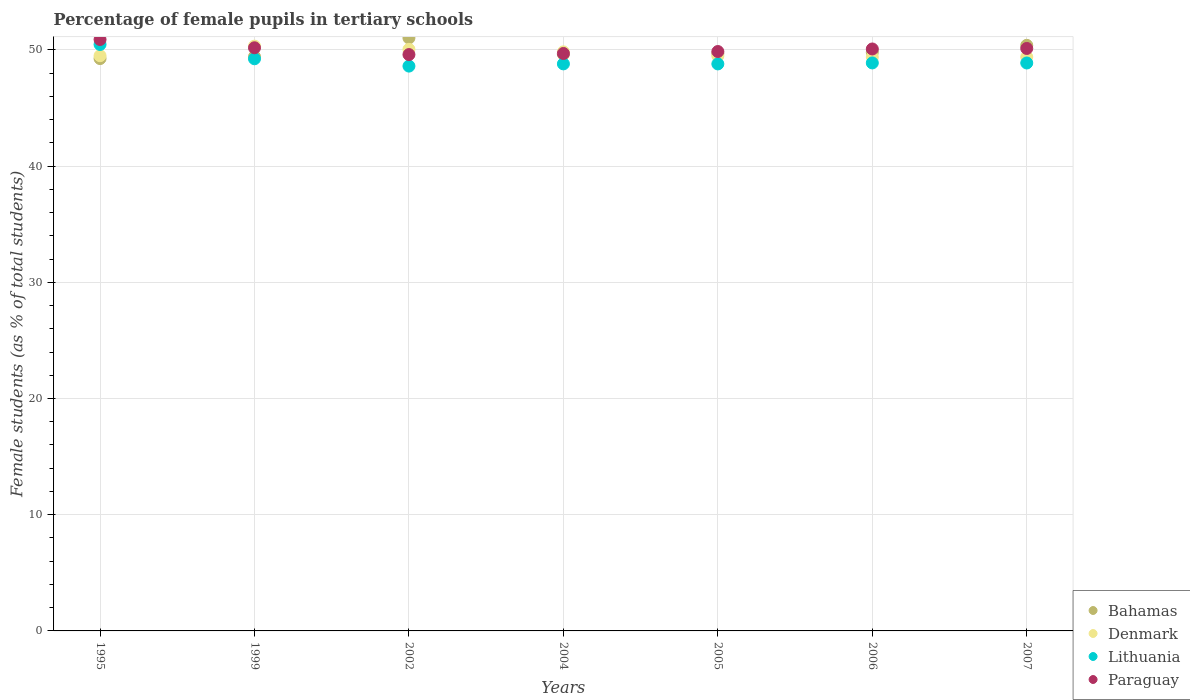Is the number of dotlines equal to the number of legend labels?
Keep it short and to the point. Yes. What is the percentage of female pupils in tertiary schools in Paraguay in 1999?
Make the answer very short. 50.18. Across all years, what is the maximum percentage of female pupils in tertiary schools in Paraguay?
Give a very brief answer. 50.9. Across all years, what is the minimum percentage of female pupils in tertiary schools in Denmark?
Provide a succinct answer. 49.38. In which year was the percentage of female pupils in tertiary schools in Denmark maximum?
Offer a terse response. 1999. What is the total percentage of female pupils in tertiary schools in Bahamas in the graph?
Your response must be concise. 349.22. What is the difference between the percentage of female pupils in tertiary schools in Lithuania in 1999 and that in 2002?
Provide a short and direct response. 0.63. What is the difference between the percentage of female pupils in tertiary schools in Denmark in 2004 and the percentage of female pupils in tertiary schools in Bahamas in 2007?
Your answer should be very brief. -0.56. What is the average percentage of female pupils in tertiary schools in Denmark per year?
Your answer should be very brief. 49.71. In the year 1995, what is the difference between the percentage of female pupils in tertiary schools in Denmark and percentage of female pupils in tertiary schools in Paraguay?
Your response must be concise. -1.4. In how many years, is the percentage of female pupils in tertiary schools in Bahamas greater than 32 %?
Provide a succinct answer. 7. What is the ratio of the percentage of female pupils in tertiary schools in Denmark in 1999 to that in 2006?
Make the answer very short. 1.02. Is the percentage of female pupils in tertiary schools in Lithuania in 1999 less than that in 2005?
Offer a very short reply. No. What is the difference between the highest and the second highest percentage of female pupils in tertiary schools in Paraguay?
Make the answer very short. 0.71. What is the difference between the highest and the lowest percentage of female pupils in tertiary schools in Denmark?
Your answer should be compact. 0.94. Is the sum of the percentage of female pupils in tertiary schools in Lithuania in 2002 and 2007 greater than the maximum percentage of female pupils in tertiary schools in Paraguay across all years?
Offer a very short reply. Yes. Is the percentage of female pupils in tertiary schools in Paraguay strictly less than the percentage of female pupils in tertiary schools in Denmark over the years?
Give a very brief answer. No. What is the difference between two consecutive major ticks on the Y-axis?
Offer a very short reply. 10. Are the values on the major ticks of Y-axis written in scientific E-notation?
Provide a short and direct response. No. How many legend labels are there?
Offer a very short reply. 4. What is the title of the graph?
Give a very brief answer. Percentage of female pupils in tertiary schools. What is the label or title of the X-axis?
Your response must be concise. Years. What is the label or title of the Y-axis?
Provide a short and direct response. Female students (as % of total students). What is the Female students (as % of total students) in Bahamas in 1995?
Keep it short and to the point. 49.25. What is the Female students (as % of total students) of Denmark in 1995?
Offer a very short reply. 49.5. What is the Female students (as % of total students) in Lithuania in 1995?
Ensure brevity in your answer.  50.47. What is the Female students (as % of total students) of Paraguay in 1995?
Your response must be concise. 50.9. What is the Female students (as % of total students) of Bahamas in 1999?
Provide a short and direct response. 49.43. What is the Female students (as % of total students) in Denmark in 1999?
Your answer should be very brief. 50.32. What is the Female students (as % of total students) in Lithuania in 1999?
Your answer should be compact. 49.24. What is the Female students (as % of total students) of Paraguay in 1999?
Make the answer very short. 50.18. What is the Female students (as % of total students) in Bahamas in 2002?
Ensure brevity in your answer.  51.03. What is the Female students (as % of total students) of Denmark in 2002?
Make the answer very short. 50.05. What is the Female students (as % of total students) of Lithuania in 2002?
Keep it short and to the point. 48.61. What is the Female students (as % of total students) in Paraguay in 2002?
Provide a short and direct response. 49.6. What is the Female students (as % of total students) in Bahamas in 2004?
Provide a short and direct response. 49.62. What is the Female students (as % of total students) in Denmark in 2004?
Ensure brevity in your answer.  49.83. What is the Female students (as % of total students) in Lithuania in 2004?
Provide a succinct answer. 48.8. What is the Female students (as % of total students) of Paraguay in 2004?
Make the answer very short. 49.69. What is the Female students (as % of total students) of Bahamas in 2005?
Ensure brevity in your answer.  49.71. What is the Female students (as % of total students) in Denmark in 2005?
Your response must be concise. 49.48. What is the Female students (as % of total students) in Lithuania in 2005?
Make the answer very short. 48.79. What is the Female students (as % of total students) in Paraguay in 2005?
Keep it short and to the point. 49.86. What is the Female students (as % of total students) of Bahamas in 2006?
Your response must be concise. 49.8. What is the Female students (as % of total students) of Denmark in 2006?
Provide a succinct answer. 49.38. What is the Female students (as % of total students) of Lithuania in 2006?
Offer a very short reply. 48.88. What is the Female students (as % of total students) of Paraguay in 2006?
Offer a terse response. 50.08. What is the Female students (as % of total students) in Bahamas in 2007?
Ensure brevity in your answer.  50.39. What is the Female students (as % of total students) of Denmark in 2007?
Your response must be concise. 49.39. What is the Female students (as % of total students) in Lithuania in 2007?
Give a very brief answer. 48.87. What is the Female students (as % of total students) in Paraguay in 2007?
Your answer should be compact. 50.12. Across all years, what is the maximum Female students (as % of total students) of Bahamas?
Your response must be concise. 51.03. Across all years, what is the maximum Female students (as % of total students) in Denmark?
Make the answer very short. 50.32. Across all years, what is the maximum Female students (as % of total students) of Lithuania?
Offer a very short reply. 50.47. Across all years, what is the maximum Female students (as % of total students) of Paraguay?
Your response must be concise. 50.9. Across all years, what is the minimum Female students (as % of total students) in Bahamas?
Keep it short and to the point. 49.25. Across all years, what is the minimum Female students (as % of total students) of Denmark?
Provide a succinct answer. 49.38. Across all years, what is the minimum Female students (as % of total students) in Lithuania?
Your response must be concise. 48.61. Across all years, what is the minimum Female students (as % of total students) in Paraguay?
Keep it short and to the point. 49.6. What is the total Female students (as % of total students) in Bahamas in the graph?
Your response must be concise. 349.23. What is the total Female students (as % of total students) in Denmark in the graph?
Your response must be concise. 347.96. What is the total Female students (as % of total students) of Lithuania in the graph?
Give a very brief answer. 343.66. What is the total Female students (as % of total students) in Paraguay in the graph?
Offer a very short reply. 350.44. What is the difference between the Female students (as % of total students) in Bahamas in 1995 and that in 1999?
Provide a succinct answer. -0.17. What is the difference between the Female students (as % of total students) of Denmark in 1995 and that in 1999?
Give a very brief answer. -0.82. What is the difference between the Female students (as % of total students) of Lithuania in 1995 and that in 1999?
Offer a very short reply. 1.23. What is the difference between the Female students (as % of total students) of Paraguay in 1995 and that in 1999?
Provide a succinct answer. 0.71. What is the difference between the Female students (as % of total students) of Bahamas in 1995 and that in 2002?
Offer a terse response. -1.77. What is the difference between the Female students (as % of total students) in Denmark in 1995 and that in 2002?
Keep it short and to the point. -0.55. What is the difference between the Female students (as % of total students) in Lithuania in 1995 and that in 2002?
Your answer should be very brief. 1.86. What is the difference between the Female students (as % of total students) of Paraguay in 1995 and that in 2002?
Provide a short and direct response. 1.3. What is the difference between the Female students (as % of total students) in Bahamas in 1995 and that in 2004?
Provide a short and direct response. -0.37. What is the difference between the Female students (as % of total students) in Denmark in 1995 and that in 2004?
Your response must be concise. -0.33. What is the difference between the Female students (as % of total students) in Lithuania in 1995 and that in 2004?
Your response must be concise. 1.67. What is the difference between the Female students (as % of total students) of Paraguay in 1995 and that in 2004?
Make the answer very short. 1.2. What is the difference between the Female students (as % of total students) of Bahamas in 1995 and that in 2005?
Your answer should be very brief. -0.45. What is the difference between the Female students (as % of total students) in Denmark in 1995 and that in 2005?
Ensure brevity in your answer.  0.02. What is the difference between the Female students (as % of total students) of Lithuania in 1995 and that in 2005?
Offer a terse response. 1.67. What is the difference between the Female students (as % of total students) of Paraguay in 1995 and that in 2005?
Ensure brevity in your answer.  1.04. What is the difference between the Female students (as % of total students) of Bahamas in 1995 and that in 2006?
Provide a succinct answer. -0.55. What is the difference between the Female students (as % of total students) in Denmark in 1995 and that in 2006?
Offer a terse response. 0.12. What is the difference between the Female students (as % of total students) of Lithuania in 1995 and that in 2006?
Offer a very short reply. 1.59. What is the difference between the Female students (as % of total students) in Paraguay in 1995 and that in 2006?
Ensure brevity in your answer.  0.82. What is the difference between the Female students (as % of total students) in Bahamas in 1995 and that in 2007?
Make the answer very short. -1.14. What is the difference between the Female students (as % of total students) in Denmark in 1995 and that in 2007?
Your answer should be compact. 0.11. What is the difference between the Female students (as % of total students) in Lithuania in 1995 and that in 2007?
Provide a succinct answer. 1.59. What is the difference between the Female students (as % of total students) of Paraguay in 1995 and that in 2007?
Keep it short and to the point. 0.77. What is the difference between the Female students (as % of total students) of Bahamas in 1999 and that in 2002?
Your answer should be very brief. -1.6. What is the difference between the Female students (as % of total students) in Denmark in 1999 and that in 2002?
Offer a very short reply. 0.28. What is the difference between the Female students (as % of total students) of Lithuania in 1999 and that in 2002?
Offer a very short reply. 0.63. What is the difference between the Female students (as % of total students) in Paraguay in 1999 and that in 2002?
Your answer should be very brief. 0.59. What is the difference between the Female students (as % of total students) of Bahamas in 1999 and that in 2004?
Keep it short and to the point. -0.2. What is the difference between the Female students (as % of total students) of Denmark in 1999 and that in 2004?
Provide a succinct answer. 0.49. What is the difference between the Female students (as % of total students) of Lithuania in 1999 and that in 2004?
Provide a succinct answer. 0.44. What is the difference between the Female students (as % of total students) of Paraguay in 1999 and that in 2004?
Your answer should be very brief. 0.49. What is the difference between the Female students (as % of total students) in Bahamas in 1999 and that in 2005?
Provide a succinct answer. -0.28. What is the difference between the Female students (as % of total students) in Denmark in 1999 and that in 2005?
Keep it short and to the point. 0.84. What is the difference between the Female students (as % of total students) of Lithuania in 1999 and that in 2005?
Offer a very short reply. 0.44. What is the difference between the Female students (as % of total students) in Paraguay in 1999 and that in 2005?
Keep it short and to the point. 0.32. What is the difference between the Female students (as % of total students) in Bahamas in 1999 and that in 2006?
Keep it short and to the point. -0.37. What is the difference between the Female students (as % of total students) in Denmark in 1999 and that in 2006?
Offer a very short reply. 0.94. What is the difference between the Female students (as % of total students) in Lithuania in 1999 and that in 2006?
Give a very brief answer. 0.36. What is the difference between the Female students (as % of total students) in Paraguay in 1999 and that in 2006?
Provide a short and direct response. 0.1. What is the difference between the Female students (as % of total students) in Bahamas in 1999 and that in 2007?
Your answer should be very brief. -0.97. What is the difference between the Female students (as % of total students) in Denmark in 1999 and that in 2007?
Give a very brief answer. 0.93. What is the difference between the Female students (as % of total students) of Lithuania in 1999 and that in 2007?
Your answer should be very brief. 0.36. What is the difference between the Female students (as % of total students) in Paraguay in 1999 and that in 2007?
Offer a terse response. 0.06. What is the difference between the Female students (as % of total students) in Bahamas in 2002 and that in 2004?
Ensure brevity in your answer.  1.4. What is the difference between the Female students (as % of total students) of Denmark in 2002 and that in 2004?
Your response must be concise. 0.22. What is the difference between the Female students (as % of total students) of Lithuania in 2002 and that in 2004?
Provide a short and direct response. -0.19. What is the difference between the Female students (as % of total students) of Paraguay in 2002 and that in 2004?
Make the answer very short. -0.09. What is the difference between the Female students (as % of total students) in Bahamas in 2002 and that in 2005?
Offer a terse response. 1.32. What is the difference between the Female students (as % of total students) in Denmark in 2002 and that in 2005?
Your answer should be very brief. 0.57. What is the difference between the Female students (as % of total students) of Lithuania in 2002 and that in 2005?
Offer a very short reply. -0.19. What is the difference between the Female students (as % of total students) of Paraguay in 2002 and that in 2005?
Provide a short and direct response. -0.26. What is the difference between the Female students (as % of total students) in Bahamas in 2002 and that in 2006?
Ensure brevity in your answer.  1.23. What is the difference between the Female students (as % of total students) of Denmark in 2002 and that in 2006?
Make the answer very short. 0.67. What is the difference between the Female students (as % of total students) in Lithuania in 2002 and that in 2006?
Ensure brevity in your answer.  -0.27. What is the difference between the Female students (as % of total students) in Paraguay in 2002 and that in 2006?
Your answer should be very brief. -0.48. What is the difference between the Female students (as % of total students) of Bahamas in 2002 and that in 2007?
Make the answer very short. 0.63. What is the difference between the Female students (as % of total students) in Denmark in 2002 and that in 2007?
Offer a terse response. 0.66. What is the difference between the Female students (as % of total students) in Lithuania in 2002 and that in 2007?
Your answer should be very brief. -0.27. What is the difference between the Female students (as % of total students) in Paraguay in 2002 and that in 2007?
Offer a terse response. -0.53. What is the difference between the Female students (as % of total students) of Bahamas in 2004 and that in 2005?
Give a very brief answer. -0.08. What is the difference between the Female students (as % of total students) in Denmark in 2004 and that in 2005?
Your answer should be compact. 0.35. What is the difference between the Female students (as % of total students) in Lithuania in 2004 and that in 2005?
Give a very brief answer. 0. What is the difference between the Female students (as % of total students) in Paraguay in 2004 and that in 2005?
Give a very brief answer. -0.17. What is the difference between the Female students (as % of total students) of Bahamas in 2004 and that in 2006?
Give a very brief answer. -0.18. What is the difference between the Female students (as % of total students) in Denmark in 2004 and that in 2006?
Ensure brevity in your answer.  0.45. What is the difference between the Female students (as % of total students) of Lithuania in 2004 and that in 2006?
Give a very brief answer. -0.08. What is the difference between the Female students (as % of total students) in Paraguay in 2004 and that in 2006?
Offer a terse response. -0.39. What is the difference between the Female students (as % of total students) in Bahamas in 2004 and that in 2007?
Offer a very short reply. -0.77. What is the difference between the Female students (as % of total students) of Denmark in 2004 and that in 2007?
Keep it short and to the point. 0.44. What is the difference between the Female students (as % of total students) in Lithuania in 2004 and that in 2007?
Keep it short and to the point. -0.08. What is the difference between the Female students (as % of total students) in Paraguay in 2004 and that in 2007?
Provide a succinct answer. -0.43. What is the difference between the Female students (as % of total students) in Bahamas in 2005 and that in 2006?
Ensure brevity in your answer.  -0.09. What is the difference between the Female students (as % of total students) in Denmark in 2005 and that in 2006?
Provide a succinct answer. 0.1. What is the difference between the Female students (as % of total students) of Lithuania in 2005 and that in 2006?
Your answer should be very brief. -0.09. What is the difference between the Female students (as % of total students) of Paraguay in 2005 and that in 2006?
Provide a short and direct response. -0.22. What is the difference between the Female students (as % of total students) in Bahamas in 2005 and that in 2007?
Ensure brevity in your answer.  -0.69. What is the difference between the Female students (as % of total students) of Denmark in 2005 and that in 2007?
Keep it short and to the point. 0.09. What is the difference between the Female students (as % of total students) of Lithuania in 2005 and that in 2007?
Your response must be concise. -0.08. What is the difference between the Female students (as % of total students) in Paraguay in 2005 and that in 2007?
Keep it short and to the point. -0.26. What is the difference between the Female students (as % of total students) in Bahamas in 2006 and that in 2007?
Your response must be concise. -0.59. What is the difference between the Female students (as % of total students) in Denmark in 2006 and that in 2007?
Make the answer very short. -0.01. What is the difference between the Female students (as % of total students) of Lithuania in 2006 and that in 2007?
Give a very brief answer. 0.01. What is the difference between the Female students (as % of total students) in Paraguay in 2006 and that in 2007?
Provide a short and direct response. -0.04. What is the difference between the Female students (as % of total students) of Bahamas in 1995 and the Female students (as % of total students) of Denmark in 1999?
Provide a short and direct response. -1.07. What is the difference between the Female students (as % of total students) in Bahamas in 1995 and the Female students (as % of total students) in Lithuania in 1999?
Offer a terse response. 0.02. What is the difference between the Female students (as % of total students) of Bahamas in 1995 and the Female students (as % of total students) of Paraguay in 1999?
Provide a succinct answer. -0.93. What is the difference between the Female students (as % of total students) of Denmark in 1995 and the Female students (as % of total students) of Lithuania in 1999?
Keep it short and to the point. 0.26. What is the difference between the Female students (as % of total students) of Denmark in 1995 and the Female students (as % of total students) of Paraguay in 1999?
Make the answer very short. -0.68. What is the difference between the Female students (as % of total students) in Lithuania in 1995 and the Female students (as % of total students) in Paraguay in 1999?
Your answer should be very brief. 0.28. What is the difference between the Female students (as % of total students) in Bahamas in 1995 and the Female students (as % of total students) in Denmark in 2002?
Give a very brief answer. -0.8. What is the difference between the Female students (as % of total students) in Bahamas in 1995 and the Female students (as % of total students) in Lithuania in 2002?
Keep it short and to the point. 0.65. What is the difference between the Female students (as % of total students) of Bahamas in 1995 and the Female students (as % of total students) of Paraguay in 2002?
Your answer should be compact. -0.35. What is the difference between the Female students (as % of total students) of Denmark in 1995 and the Female students (as % of total students) of Lithuania in 2002?
Offer a terse response. 0.89. What is the difference between the Female students (as % of total students) of Denmark in 1995 and the Female students (as % of total students) of Paraguay in 2002?
Ensure brevity in your answer.  -0.1. What is the difference between the Female students (as % of total students) of Lithuania in 1995 and the Female students (as % of total students) of Paraguay in 2002?
Provide a succinct answer. 0.87. What is the difference between the Female students (as % of total students) of Bahamas in 1995 and the Female students (as % of total students) of Denmark in 2004?
Offer a terse response. -0.58. What is the difference between the Female students (as % of total students) in Bahamas in 1995 and the Female students (as % of total students) in Lithuania in 2004?
Give a very brief answer. 0.46. What is the difference between the Female students (as % of total students) in Bahamas in 1995 and the Female students (as % of total students) in Paraguay in 2004?
Your response must be concise. -0.44. What is the difference between the Female students (as % of total students) of Denmark in 1995 and the Female students (as % of total students) of Lithuania in 2004?
Your response must be concise. 0.7. What is the difference between the Female students (as % of total students) of Denmark in 1995 and the Female students (as % of total students) of Paraguay in 2004?
Provide a short and direct response. -0.19. What is the difference between the Female students (as % of total students) in Lithuania in 1995 and the Female students (as % of total students) in Paraguay in 2004?
Make the answer very short. 0.77. What is the difference between the Female students (as % of total students) in Bahamas in 1995 and the Female students (as % of total students) in Denmark in 2005?
Ensure brevity in your answer.  -0.23. What is the difference between the Female students (as % of total students) in Bahamas in 1995 and the Female students (as % of total students) in Lithuania in 2005?
Ensure brevity in your answer.  0.46. What is the difference between the Female students (as % of total students) of Bahamas in 1995 and the Female students (as % of total students) of Paraguay in 2005?
Provide a short and direct response. -0.61. What is the difference between the Female students (as % of total students) in Denmark in 1995 and the Female students (as % of total students) in Lithuania in 2005?
Your answer should be very brief. 0.71. What is the difference between the Female students (as % of total students) of Denmark in 1995 and the Female students (as % of total students) of Paraguay in 2005?
Provide a succinct answer. -0.36. What is the difference between the Female students (as % of total students) in Lithuania in 1995 and the Female students (as % of total students) in Paraguay in 2005?
Your response must be concise. 0.61. What is the difference between the Female students (as % of total students) of Bahamas in 1995 and the Female students (as % of total students) of Denmark in 2006?
Your response must be concise. -0.13. What is the difference between the Female students (as % of total students) of Bahamas in 1995 and the Female students (as % of total students) of Lithuania in 2006?
Your answer should be compact. 0.37. What is the difference between the Female students (as % of total students) of Bahamas in 1995 and the Female students (as % of total students) of Paraguay in 2006?
Your response must be concise. -0.83. What is the difference between the Female students (as % of total students) in Denmark in 1995 and the Female students (as % of total students) in Lithuania in 2006?
Make the answer very short. 0.62. What is the difference between the Female students (as % of total students) in Denmark in 1995 and the Female students (as % of total students) in Paraguay in 2006?
Your response must be concise. -0.58. What is the difference between the Female students (as % of total students) in Lithuania in 1995 and the Female students (as % of total students) in Paraguay in 2006?
Your response must be concise. 0.39. What is the difference between the Female students (as % of total students) in Bahamas in 1995 and the Female students (as % of total students) in Denmark in 2007?
Provide a short and direct response. -0.14. What is the difference between the Female students (as % of total students) of Bahamas in 1995 and the Female students (as % of total students) of Lithuania in 2007?
Make the answer very short. 0.38. What is the difference between the Female students (as % of total students) in Bahamas in 1995 and the Female students (as % of total students) in Paraguay in 2007?
Offer a terse response. -0.87. What is the difference between the Female students (as % of total students) in Denmark in 1995 and the Female students (as % of total students) in Lithuania in 2007?
Keep it short and to the point. 0.63. What is the difference between the Female students (as % of total students) of Denmark in 1995 and the Female students (as % of total students) of Paraguay in 2007?
Give a very brief answer. -0.62. What is the difference between the Female students (as % of total students) in Lithuania in 1995 and the Female students (as % of total students) in Paraguay in 2007?
Ensure brevity in your answer.  0.34. What is the difference between the Female students (as % of total students) of Bahamas in 1999 and the Female students (as % of total students) of Denmark in 2002?
Keep it short and to the point. -0.62. What is the difference between the Female students (as % of total students) of Bahamas in 1999 and the Female students (as % of total students) of Lithuania in 2002?
Provide a succinct answer. 0.82. What is the difference between the Female students (as % of total students) of Bahamas in 1999 and the Female students (as % of total students) of Paraguay in 2002?
Keep it short and to the point. -0.17. What is the difference between the Female students (as % of total students) of Denmark in 1999 and the Female students (as % of total students) of Lithuania in 2002?
Your answer should be very brief. 1.72. What is the difference between the Female students (as % of total students) of Denmark in 1999 and the Female students (as % of total students) of Paraguay in 2002?
Provide a short and direct response. 0.73. What is the difference between the Female students (as % of total students) of Lithuania in 1999 and the Female students (as % of total students) of Paraguay in 2002?
Your answer should be very brief. -0.36. What is the difference between the Female students (as % of total students) of Bahamas in 1999 and the Female students (as % of total students) of Denmark in 2004?
Offer a very short reply. -0.41. What is the difference between the Female students (as % of total students) of Bahamas in 1999 and the Female students (as % of total students) of Lithuania in 2004?
Give a very brief answer. 0.63. What is the difference between the Female students (as % of total students) of Bahamas in 1999 and the Female students (as % of total students) of Paraguay in 2004?
Ensure brevity in your answer.  -0.27. What is the difference between the Female students (as % of total students) of Denmark in 1999 and the Female students (as % of total students) of Lithuania in 2004?
Give a very brief answer. 1.53. What is the difference between the Female students (as % of total students) in Denmark in 1999 and the Female students (as % of total students) in Paraguay in 2004?
Offer a very short reply. 0.63. What is the difference between the Female students (as % of total students) in Lithuania in 1999 and the Female students (as % of total students) in Paraguay in 2004?
Your answer should be very brief. -0.46. What is the difference between the Female students (as % of total students) of Bahamas in 1999 and the Female students (as % of total students) of Denmark in 2005?
Make the answer very short. -0.06. What is the difference between the Female students (as % of total students) in Bahamas in 1999 and the Female students (as % of total students) in Lithuania in 2005?
Your response must be concise. 0.63. What is the difference between the Female students (as % of total students) in Bahamas in 1999 and the Female students (as % of total students) in Paraguay in 2005?
Ensure brevity in your answer.  -0.44. What is the difference between the Female students (as % of total students) of Denmark in 1999 and the Female students (as % of total students) of Lithuania in 2005?
Give a very brief answer. 1.53. What is the difference between the Female students (as % of total students) of Denmark in 1999 and the Female students (as % of total students) of Paraguay in 2005?
Your response must be concise. 0.46. What is the difference between the Female students (as % of total students) in Lithuania in 1999 and the Female students (as % of total students) in Paraguay in 2005?
Provide a short and direct response. -0.62. What is the difference between the Female students (as % of total students) in Bahamas in 1999 and the Female students (as % of total students) in Denmark in 2006?
Give a very brief answer. 0.04. What is the difference between the Female students (as % of total students) in Bahamas in 1999 and the Female students (as % of total students) in Lithuania in 2006?
Offer a very short reply. 0.55. What is the difference between the Female students (as % of total students) of Bahamas in 1999 and the Female students (as % of total students) of Paraguay in 2006?
Your answer should be very brief. -0.66. What is the difference between the Female students (as % of total students) of Denmark in 1999 and the Female students (as % of total students) of Lithuania in 2006?
Offer a terse response. 1.44. What is the difference between the Female students (as % of total students) of Denmark in 1999 and the Female students (as % of total students) of Paraguay in 2006?
Keep it short and to the point. 0.24. What is the difference between the Female students (as % of total students) in Lithuania in 1999 and the Female students (as % of total students) in Paraguay in 2006?
Your response must be concise. -0.84. What is the difference between the Female students (as % of total students) in Bahamas in 1999 and the Female students (as % of total students) in Denmark in 2007?
Ensure brevity in your answer.  0.03. What is the difference between the Female students (as % of total students) of Bahamas in 1999 and the Female students (as % of total students) of Lithuania in 2007?
Offer a very short reply. 0.55. What is the difference between the Female students (as % of total students) of Bahamas in 1999 and the Female students (as % of total students) of Paraguay in 2007?
Make the answer very short. -0.7. What is the difference between the Female students (as % of total students) in Denmark in 1999 and the Female students (as % of total students) in Lithuania in 2007?
Provide a short and direct response. 1.45. What is the difference between the Female students (as % of total students) in Denmark in 1999 and the Female students (as % of total students) in Paraguay in 2007?
Offer a very short reply. 0.2. What is the difference between the Female students (as % of total students) of Lithuania in 1999 and the Female students (as % of total students) of Paraguay in 2007?
Your answer should be very brief. -0.89. What is the difference between the Female students (as % of total students) in Bahamas in 2002 and the Female students (as % of total students) in Denmark in 2004?
Your answer should be compact. 1.19. What is the difference between the Female students (as % of total students) of Bahamas in 2002 and the Female students (as % of total students) of Lithuania in 2004?
Make the answer very short. 2.23. What is the difference between the Female students (as % of total students) in Bahamas in 2002 and the Female students (as % of total students) in Paraguay in 2004?
Keep it short and to the point. 1.33. What is the difference between the Female students (as % of total students) of Denmark in 2002 and the Female students (as % of total students) of Lithuania in 2004?
Your answer should be very brief. 1.25. What is the difference between the Female students (as % of total students) in Denmark in 2002 and the Female students (as % of total students) in Paraguay in 2004?
Keep it short and to the point. 0.36. What is the difference between the Female students (as % of total students) in Lithuania in 2002 and the Female students (as % of total students) in Paraguay in 2004?
Your response must be concise. -1.09. What is the difference between the Female students (as % of total students) of Bahamas in 2002 and the Female students (as % of total students) of Denmark in 2005?
Your answer should be compact. 1.55. What is the difference between the Female students (as % of total students) in Bahamas in 2002 and the Female students (as % of total students) in Lithuania in 2005?
Provide a succinct answer. 2.23. What is the difference between the Female students (as % of total students) of Bahamas in 2002 and the Female students (as % of total students) of Paraguay in 2005?
Provide a succinct answer. 1.17. What is the difference between the Female students (as % of total students) of Denmark in 2002 and the Female students (as % of total students) of Lithuania in 2005?
Make the answer very short. 1.25. What is the difference between the Female students (as % of total students) in Denmark in 2002 and the Female students (as % of total students) in Paraguay in 2005?
Your answer should be very brief. 0.19. What is the difference between the Female students (as % of total students) in Lithuania in 2002 and the Female students (as % of total students) in Paraguay in 2005?
Your answer should be compact. -1.25. What is the difference between the Female students (as % of total students) in Bahamas in 2002 and the Female students (as % of total students) in Denmark in 2006?
Provide a short and direct response. 1.65. What is the difference between the Female students (as % of total students) of Bahamas in 2002 and the Female students (as % of total students) of Lithuania in 2006?
Your response must be concise. 2.15. What is the difference between the Female students (as % of total students) of Bahamas in 2002 and the Female students (as % of total students) of Paraguay in 2006?
Provide a short and direct response. 0.95. What is the difference between the Female students (as % of total students) of Denmark in 2002 and the Female students (as % of total students) of Lithuania in 2006?
Your answer should be very brief. 1.17. What is the difference between the Female students (as % of total students) of Denmark in 2002 and the Female students (as % of total students) of Paraguay in 2006?
Offer a terse response. -0.03. What is the difference between the Female students (as % of total students) in Lithuania in 2002 and the Female students (as % of total students) in Paraguay in 2006?
Provide a succinct answer. -1.47. What is the difference between the Female students (as % of total students) of Bahamas in 2002 and the Female students (as % of total students) of Denmark in 2007?
Offer a very short reply. 1.64. What is the difference between the Female students (as % of total students) in Bahamas in 2002 and the Female students (as % of total students) in Lithuania in 2007?
Provide a succinct answer. 2.15. What is the difference between the Female students (as % of total students) in Bahamas in 2002 and the Female students (as % of total students) in Paraguay in 2007?
Offer a terse response. 0.9. What is the difference between the Female students (as % of total students) in Denmark in 2002 and the Female students (as % of total students) in Lithuania in 2007?
Offer a terse response. 1.17. What is the difference between the Female students (as % of total students) of Denmark in 2002 and the Female students (as % of total students) of Paraguay in 2007?
Ensure brevity in your answer.  -0.08. What is the difference between the Female students (as % of total students) in Lithuania in 2002 and the Female students (as % of total students) in Paraguay in 2007?
Provide a short and direct response. -1.52. What is the difference between the Female students (as % of total students) in Bahamas in 2004 and the Female students (as % of total students) in Denmark in 2005?
Your answer should be very brief. 0.14. What is the difference between the Female students (as % of total students) in Bahamas in 2004 and the Female students (as % of total students) in Lithuania in 2005?
Provide a succinct answer. 0.83. What is the difference between the Female students (as % of total students) of Bahamas in 2004 and the Female students (as % of total students) of Paraguay in 2005?
Make the answer very short. -0.24. What is the difference between the Female students (as % of total students) of Denmark in 2004 and the Female students (as % of total students) of Lithuania in 2005?
Offer a very short reply. 1.04. What is the difference between the Female students (as % of total students) in Denmark in 2004 and the Female students (as % of total students) in Paraguay in 2005?
Keep it short and to the point. -0.03. What is the difference between the Female students (as % of total students) in Lithuania in 2004 and the Female students (as % of total students) in Paraguay in 2005?
Offer a terse response. -1.06. What is the difference between the Female students (as % of total students) in Bahamas in 2004 and the Female students (as % of total students) in Denmark in 2006?
Give a very brief answer. 0.24. What is the difference between the Female students (as % of total students) of Bahamas in 2004 and the Female students (as % of total students) of Lithuania in 2006?
Make the answer very short. 0.74. What is the difference between the Female students (as % of total students) in Bahamas in 2004 and the Female students (as % of total students) in Paraguay in 2006?
Offer a terse response. -0.46. What is the difference between the Female students (as % of total students) in Denmark in 2004 and the Female students (as % of total students) in Lithuania in 2006?
Provide a succinct answer. 0.95. What is the difference between the Female students (as % of total students) in Denmark in 2004 and the Female students (as % of total students) in Paraguay in 2006?
Make the answer very short. -0.25. What is the difference between the Female students (as % of total students) of Lithuania in 2004 and the Female students (as % of total students) of Paraguay in 2006?
Offer a terse response. -1.28. What is the difference between the Female students (as % of total students) in Bahamas in 2004 and the Female students (as % of total students) in Denmark in 2007?
Give a very brief answer. 0.23. What is the difference between the Female students (as % of total students) of Bahamas in 2004 and the Female students (as % of total students) of Lithuania in 2007?
Your answer should be compact. 0.75. What is the difference between the Female students (as % of total students) in Bahamas in 2004 and the Female students (as % of total students) in Paraguay in 2007?
Provide a short and direct response. -0.5. What is the difference between the Female students (as % of total students) in Denmark in 2004 and the Female students (as % of total students) in Lithuania in 2007?
Provide a succinct answer. 0.96. What is the difference between the Female students (as % of total students) in Denmark in 2004 and the Female students (as % of total students) in Paraguay in 2007?
Your answer should be compact. -0.29. What is the difference between the Female students (as % of total students) of Lithuania in 2004 and the Female students (as % of total students) of Paraguay in 2007?
Keep it short and to the point. -1.33. What is the difference between the Female students (as % of total students) in Bahamas in 2005 and the Female students (as % of total students) in Denmark in 2006?
Offer a terse response. 0.33. What is the difference between the Female students (as % of total students) of Bahamas in 2005 and the Female students (as % of total students) of Lithuania in 2006?
Make the answer very short. 0.83. What is the difference between the Female students (as % of total students) of Bahamas in 2005 and the Female students (as % of total students) of Paraguay in 2006?
Keep it short and to the point. -0.38. What is the difference between the Female students (as % of total students) in Denmark in 2005 and the Female students (as % of total students) in Lithuania in 2006?
Your answer should be compact. 0.6. What is the difference between the Female students (as % of total students) of Denmark in 2005 and the Female students (as % of total students) of Paraguay in 2006?
Your answer should be very brief. -0.6. What is the difference between the Female students (as % of total students) in Lithuania in 2005 and the Female students (as % of total students) in Paraguay in 2006?
Make the answer very short. -1.29. What is the difference between the Female students (as % of total students) of Bahamas in 2005 and the Female students (as % of total students) of Denmark in 2007?
Your response must be concise. 0.31. What is the difference between the Female students (as % of total students) of Bahamas in 2005 and the Female students (as % of total students) of Lithuania in 2007?
Provide a short and direct response. 0.83. What is the difference between the Female students (as % of total students) in Bahamas in 2005 and the Female students (as % of total students) in Paraguay in 2007?
Keep it short and to the point. -0.42. What is the difference between the Female students (as % of total students) of Denmark in 2005 and the Female students (as % of total students) of Lithuania in 2007?
Your answer should be very brief. 0.61. What is the difference between the Female students (as % of total students) of Denmark in 2005 and the Female students (as % of total students) of Paraguay in 2007?
Provide a short and direct response. -0.64. What is the difference between the Female students (as % of total students) of Lithuania in 2005 and the Female students (as % of total students) of Paraguay in 2007?
Offer a terse response. -1.33. What is the difference between the Female students (as % of total students) of Bahamas in 2006 and the Female students (as % of total students) of Denmark in 2007?
Offer a terse response. 0.41. What is the difference between the Female students (as % of total students) in Bahamas in 2006 and the Female students (as % of total students) in Lithuania in 2007?
Ensure brevity in your answer.  0.93. What is the difference between the Female students (as % of total students) in Bahamas in 2006 and the Female students (as % of total students) in Paraguay in 2007?
Your response must be concise. -0.33. What is the difference between the Female students (as % of total students) of Denmark in 2006 and the Female students (as % of total students) of Lithuania in 2007?
Your answer should be compact. 0.51. What is the difference between the Female students (as % of total students) of Denmark in 2006 and the Female students (as % of total students) of Paraguay in 2007?
Offer a very short reply. -0.74. What is the difference between the Female students (as % of total students) of Lithuania in 2006 and the Female students (as % of total students) of Paraguay in 2007?
Provide a succinct answer. -1.25. What is the average Female students (as % of total students) in Bahamas per year?
Your answer should be very brief. 49.89. What is the average Female students (as % of total students) in Denmark per year?
Your answer should be compact. 49.71. What is the average Female students (as % of total students) in Lithuania per year?
Your answer should be compact. 49.09. What is the average Female students (as % of total students) in Paraguay per year?
Provide a short and direct response. 50.06. In the year 1995, what is the difference between the Female students (as % of total students) in Bahamas and Female students (as % of total students) in Denmark?
Your answer should be very brief. -0.25. In the year 1995, what is the difference between the Female students (as % of total students) in Bahamas and Female students (as % of total students) in Lithuania?
Your answer should be compact. -1.21. In the year 1995, what is the difference between the Female students (as % of total students) of Bahamas and Female students (as % of total students) of Paraguay?
Ensure brevity in your answer.  -1.64. In the year 1995, what is the difference between the Female students (as % of total students) in Denmark and Female students (as % of total students) in Lithuania?
Give a very brief answer. -0.97. In the year 1995, what is the difference between the Female students (as % of total students) of Denmark and Female students (as % of total students) of Paraguay?
Provide a succinct answer. -1.4. In the year 1995, what is the difference between the Female students (as % of total students) in Lithuania and Female students (as % of total students) in Paraguay?
Give a very brief answer. -0.43. In the year 1999, what is the difference between the Female students (as % of total students) of Bahamas and Female students (as % of total students) of Denmark?
Your answer should be compact. -0.9. In the year 1999, what is the difference between the Female students (as % of total students) in Bahamas and Female students (as % of total students) in Lithuania?
Give a very brief answer. 0.19. In the year 1999, what is the difference between the Female students (as % of total students) of Bahamas and Female students (as % of total students) of Paraguay?
Provide a succinct answer. -0.76. In the year 1999, what is the difference between the Female students (as % of total students) of Denmark and Female students (as % of total students) of Lithuania?
Provide a short and direct response. 1.09. In the year 1999, what is the difference between the Female students (as % of total students) of Denmark and Female students (as % of total students) of Paraguay?
Provide a succinct answer. 0.14. In the year 1999, what is the difference between the Female students (as % of total students) of Lithuania and Female students (as % of total students) of Paraguay?
Ensure brevity in your answer.  -0.95. In the year 2002, what is the difference between the Female students (as % of total students) of Bahamas and Female students (as % of total students) of Denmark?
Give a very brief answer. 0.98. In the year 2002, what is the difference between the Female students (as % of total students) of Bahamas and Female students (as % of total students) of Lithuania?
Keep it short and to the point. 2.42. In the year 2002, what is the difference between the Female students (as % of total students) in Bahamas and Female students (as % of total students) in Paraguay?
Your answer should be very brief. 1.43. In the year 2002, what is the difference between the Female students (as % of total students) in Denmark and Female students (as % of total students) in Lithuania?
Give a very brief answer. 1.44. In the year 2002, what is the difference between the Female students (as % of total students) in Denmark and Female students (as % of total students) in Paraguay?
Ensure brevity in your answer.  0.45. In the year 2002, what is the difference between the Female students (as % of total students) of Lithuania and Female students (as % of total students) of Paraguay?
Your answer should be compact. -0.99. In the year 2004, what is the difference between the Female students (as % of total students) of Bahamas and Female students (as % of total students) of Denmark?
Make the answer very short. -0.21. In the year 2004, what is the difference between the Female students (as % of total students) of Bahamas and Female students (as % of total students) of Lithuania?
Provide a succinct answer. 0.83. In the year 2004, what is the difference between the Female students (as % of total students) of Bahamas and Female students (as % of total students) of Paraguay?
Provide a succinct answer. -0.07. In the year 2004, what is the difference between the Female students (as % of total students) in Denmark and Female students (as % of total students) in Lithuania?
Keep it short and to the point. 1.03. In the year 2004, what is the difference between the Female students (as % of total students) of Denmark and Female students (as % of total students) of Paraguay?
Make the answer very short. 0.14. In the year 2004, what is the difference between the Female students (as % of total students) of Lithuania and Female students (as % of total students) of Paraguay?
Ensure brevity in your answer.  -0.9. In the year 2005, what is the difference between the Female students (as % of total students) of Bahamas and Female students (as % of total students) of Denmark?
Your answer should be compact. 0.23. In the year 2005, what is the difference between the Female students (as % of total students) in Bahamas and Female students (as % of total students) in Lithuania?
Offer a very short reply. 0.91. In the year 2005, what is the difference between the Female students (as % of total students) of Bahamas and Female students (as % of total students) of Paraguay?
Give a very brief answer. -0.16. In the year 2005, what is the difference between the Female students (as % of total students) of Denmark and Female students (as % of total students) of Lithuania?
Your response must be concise. 0.69. In the year 2005, what is the difference between the Female students (as % of total students) of Denmark and Female students (as % of total students) of Paraguay?
Your answer should be compact. -0.38. In the year 2005, what is the difference between the Female students (as % of total students) of Lithuania and Female students (as % of total students) of Paraguay?
Your answer should be very brief. -1.07. In the year 2006, what is the difference between the Female students (as % of total students) in Bahamas and Female students (as % of total students) in Denmark?
Your response must be concise. 0.42. In the year 2006, what is the difference between the Female students (as % of total students) of Bahamas and Female students (as % of total students) of Lithuania?
Provide a short and direct response. 0.92. In the year 2006, what is the difference between the Female students (as % of total students) in Bahamas and Female students (as % of total students) in Paraguay?
Offer a terse response. -0.28. In the year 2006, what is the difference between the Female students (as % of total students) of Denmark and Female students (as % of total students) of Lithuania?
Your answer should be compact. 0.5. In the year 2006, what is the difference between the Female students (as % of total students) of Denmark and Female students (as % of total students) of Paraguay?
Give a very brief answer. -0.7. In the year 2006, what is the difference between the Female students (as % of total students) in Lithuania and Female students (as % of total students) in Paraguay?
Provide a succinct answer. -1.2. In the year 2007, what is the difference between the Female students (as % of total students) in Bahamas and Female students (as % of total students) in Denmark?
Make the answer very short. 1. In the year 2007, what is the difference between the Female students (as % of total students) of Bahamas and Female students (as % of total students) of Lithuania?
Your response must be concise. 1.52. In the year 2007, what is the difference between the Female students (as % of total students) in Bahamas and Female students (as % of total students) in Paraguay?
Provide a short and direct response. 0.27. In the year 2007, what is the difference between the Female students (as % of total students) of Denmark and Female students (as % of total students) of Lithuania?
Offer a terse response. 0.52. In the year 2007, what is the difference between the Female students (as % of total students) in Denmark and Female students (as % of total students) in Paraguay?
Your answer should be compact. -0.73. In the year 2007, what is the difference between the Female students (as % of total students) of Lithuania and Female students (as % of total students) of Paraguay?
Give a very brief answer. -1.25. What is the ratio of the Female students (as % of total students) in Bahamas in 1995 to that in 1999?
Make the answer very short. 1. What is the ratio of the Female students (as % of total students) of Denmark in 1995 to that in 1999?
Your response must be concise. 0.98. What is the ratio of the Female students (as % of total students) of Paraguay in 1995 to that in 1999?
Offer a terse response. 1.01. What is the ratio of the Female students (as % of total students) of Bahamas in 1995 to that in 2002?
Give a very brief answer. 0.97. What is the ratio of the Female students (as % of total students) of Lithuania in 1995 to that in 2002?
Provide a succinct answer. 1.04. What is the ratio of the Female students (as % of total students) of Paraguay in 1995 to that in 2002?
Provide a short and direct response. 1.03. What is the ratio of the Female students (as % of total students) in Denmark in 1995 to that in 2004?
Your answer should be compact. 0.99. What is the ratio of the Female students (as % of total students) of Lithuania in 1995 to that in 2004?
Ensure brevity in your answer.  1.03. What is the ratio of the Female students (as % of total students) of Paraguay in 1995 to that in 2004?
Your answer should be very brief. 1.02. What is the ratio of the Female students (as % of total students) of Bahamas in 1995 to that in 2005?
Keep it short and to the point. 0.99. What is the ratio of the Female students (as % of total students) of Denmark in 1995 to that in 2005?
Offer a very short reply. 1. What is the ratio of the Female students (as % of total students) of Lithuania in 1995 to that in 2005?
Give a very brief answer. 1.03. What is the ratio of the Female students (as % of total students) in Paraguay in 1995 to that in 2005?
Provide a short and direct response. 1.02. What is the ratio of the Female students (as % of total students) of Denmark in 1995 to that in 2006?
Ensure brevity in your answer.  1. What is the ratio of the Female students (as % of total students) in Lithuania in 1995 to that in 2006?
Provide a succinct answer. 1.03. What is the ratio of the Female students (as % of total students) of Paraguay in 1995 to that in 2006?
Give a very brief answer. 1.02. What is the ratio of the Female students (as % of total students) of Bahamas in 1995 to that in 2007?
Offer a very short reply. 0.98. What is the ratio of the Female students (as % of total students) in Lithuania in 1995 to that in 2007?
Ensure brevity in your answer.  1.03. What is the ratio of the Female students (as % of total students) in Paraguay in 1995 to that in 2007?
Provide a short and direct response. 1.02. What is the ratio of the Female students (as % of total students) in Bahamas in 1999 to that in 2002?
Your answer should be very brief. 0.97. What is the ratio of the Female students (as % of total students) of Paraguay in 1999 to that in 2002?
Ensure brevity in your answer.  1.01. What is the ratio of the Female students (as % of total students) in Bahamas in 1999 to that in 2004?
Your response must be concise. 1. What is the ratio of the Female students (as % of total students) in Denmark in 1999 to that in 2004?
Make the answer very short. 1.01. What is the ratio of the Female students (as % of total students) in Paraguay in 1999 to that in 2004?
Provide a short and direct response. 1.01. What is the ratio of the Female students (as % of total students) in Denmark in 1999 to that in 2005?
Provide a succinct answer. 1.02. What is the ratio of the Female students (as % of total students) of Lithuania in 1999 to that in 2005?
Your answer should be very brief. 1.01. What is the ratio of the Female students (as % of total students) in Paraguay in 1999 to that in 2005?
Offer a terse response. 1.01. What is the ratio of the Female students (as % of total students) in Denmark in 1999 to that in 2006?
Provide a short and direct response. 1.02. What is the ratio of the Female students (as % of total students) of Lithuania in 1999 to that in 2006?
Offer a terse response. 1.01. What is the ratio of the Female students (as % of total students) in Paraguay in 1999 to that in 2006?
Make the answer very short. 1. What is the ratio of the Female students (as % of total students) in Bahamas in 1999 to that in 2007?
Offer a very short reply. 0.98. What is the ratio of the Female students (as % of total students) of Denmark in 1999 to that in 2007?
Keep it short and to the point. 1.02. What is the ratio of the Female students (as % of total students) of Lithuania in 1999 to that in 2007?
Keep it short and to the point. 1.01. What is the ratio of the Female students (as % of total students) of Paraguay in 1999 to that in 2007?
Give a very brief answer. 1. What is the ratio of the Female students (as % of total students) of Bahamas in 2002 to that in 2004?
Your answer should be very brief. 1.03. What is the ratio of the Female students (as % of total students) of Paraguay in 2002 to that in 2004?
Offer a terse response. 1. What is the ratio of the Female students (as % of total students) of Bahamas in 2002 to that in 2005?
Offer a very short reply. 1.03. What is the ratio of the Female students (as % of total students) of Denmark in 2002 to that in 2005?
Offer a terse response. 1.01. What is the ratio of the Female students (as % of total students) in Lithuania in 2002 to that in 2005?
Provide a succinct answer. 1. What is the ratio of the Female students (as % of total students) in Paraguay in 2002 to that in 2005?
Your answer should be compact. 0.99. What is the ratio of the Female students (as % of total students) of Bahamas in 2002 to that in 2006?
Provide a short and direct response. 1.02. What is the ratio of the Female students (as % of total students) in Denmark in 2002 to that in 2006?
Your answer should be very brief. 1.01. What is the ratio of the Female students (as % of total students) in Lithuania in 2002 to that in 2006?
Your answer should be very brief. 0.99. What is the ratio of the Female students (as % of total students) in Paraguay in 2002 to that in 2006?
Provide a short and direct response. 0.99. What is the ratio of the Female students (as % of total students) in Bahamas in 2002 to that in 2007?
Offer a terse response. 1.01. What is the ratio of the Female students (as % of total students) of Denmark in 2002 to that in 2007?
Your answer should be compact. 1.01. What is the ratio of the Female students (as % of total students) in Bahamas in 2004 to that in 2005?
Your answer should be compact. 1. What is the ratio of the Female students (as % of total students) in Denmark in 2004 to that in 2005?
Give a very brief answer. 1.01. What is the ratio of the Female students (as % of total students) in Paraguay in 2004 to that in 2005?
Offer a very short reply. 1. What is the ratio of the Female students (as % of total students) of Bahamas in 2004 to that in 2006?
Ensure brevity in your answer.  1. What is the ratio of the Female students (as % of total students) in Denmark in 2004 to that in 2006?
Provide a succinct answer. 1.01. What is the ratio of the Female students (as % of total students) of Lithuania in 2004 to that in 2006?
Give a very brief answer. 1. What is the ratio of the Female students (as % of total students) in Bahamas in 2004 to that in 2007?
Give a very brief answer. 0.98. What is the ratio of the Female students (as % of total students) in Denmark in 2004 to that in 2007?
Make the answer very short. 1.01. What is the ratio of the Female students (as % of total students) in Denmark in 2005 to that in 2006?
Give a very brief answer. 1. What is the ratio of the Female students (as % of total students) in Bahamas in 2005 to that in 2007?
Ensure brevity in your answer.  0.99. What is the ratio of the Female students (as % of total students) of Bahamas in 2006 to that in 2007?
Provide a short and direct response. 0.99. What is the ratio of the Female students (as % of total students) of Paraguay in 2006 to that in 2007?
Offer a very short reply. 1. What is the difference between the highest and the second highest Female students (as % of total students) of Bahamas?
Offer a terse response. 0.63. What is the difference between the highest and the second highest Female students (as % of total students) of Denmark?
Keep it short and to the point. 0.28. What is the difference between the highest and the second highest Female students (as % of total students) in Lithuania?
Your response must be concise. 1.23. What is the difference between the highest and the second highest Female students (as % of total students) in Paraguay?
Make the answer very short. 0.71. What is the difference between the highest and the lowest Female students (as % of total students) in Bahamas?
Offer a very short reply. 1.77. What is the difference between the highest and the lowest Female students (as % of total students) in Denmark?
Give a very brief answer. 0.94. What is the difference between the highest and the lowest Female students (as % of total students) of Lithuania?
Offer a terse response. 1.86. What is the difference between the highest and the lowest Female students (as % of total students) of Paraguay?
Make the answer very short. 1.3. 